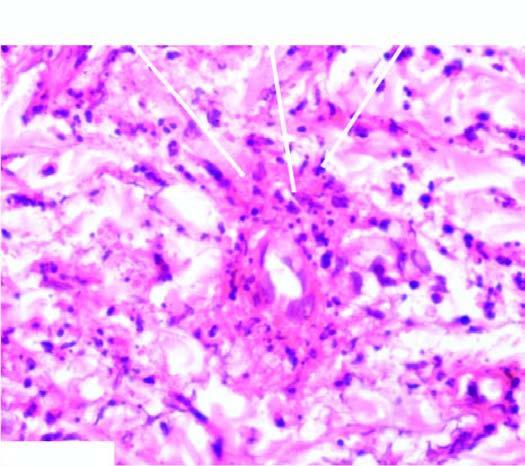does the dna virus show fibrinoid necrosis surrounded by viable as well as fragmented neutrophils?
Answer the question using a single word or phrase. No 